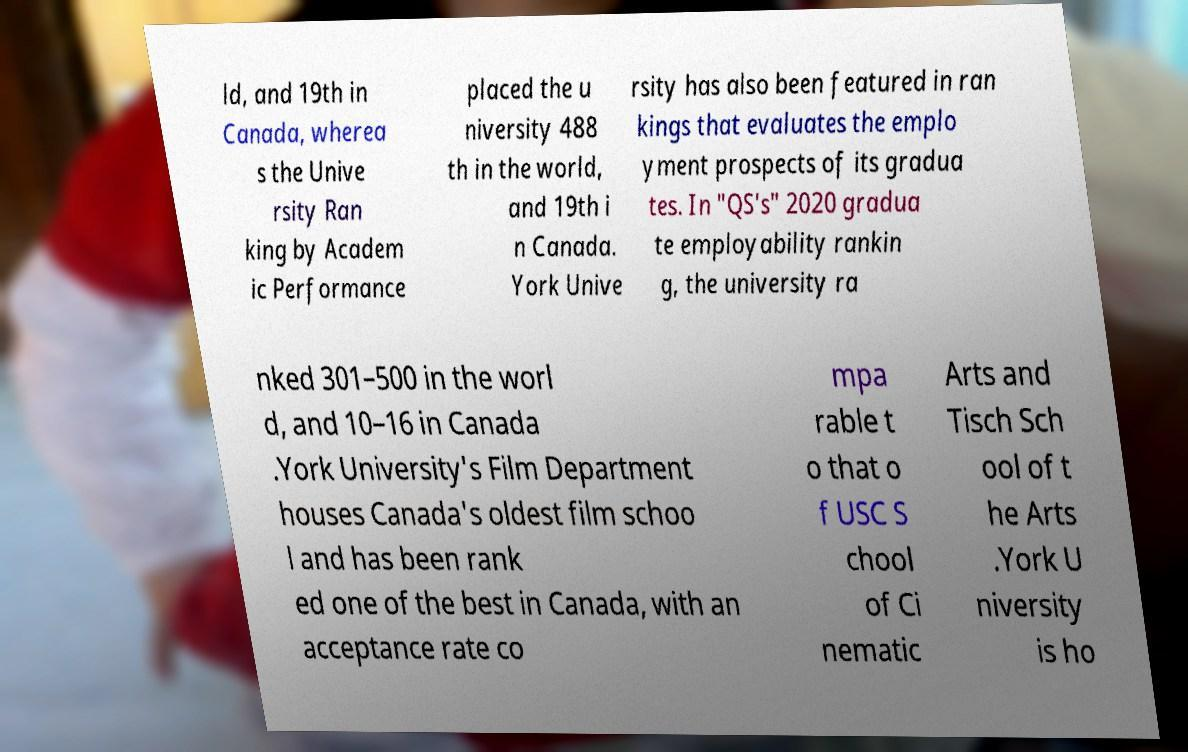Please read and relay the text visible in this image. What does it say? ld, and 19th in Canada, wherea s the Unive rsity Ran king by Academ ic Performance placed the u niversity 488 th in the world, and 19th i n Canada. York Unive rsity has also been featured in ran kings that evaluates the emplo yment prospects of its gradua tes. In "QS's" 2020 gradua te employability rankin g, the university ra nked 301–500 in the worl d, and 10–16 in Canada .York University's Film Department houses Canada's oldest film schoo l and has been rank ed one of the best in Canada, with an acceptance rate co mpa rable t o that o f USC S chool of Ci nematic Arts and Tisch Sch ool of t he Arts .York U niversity is ho 